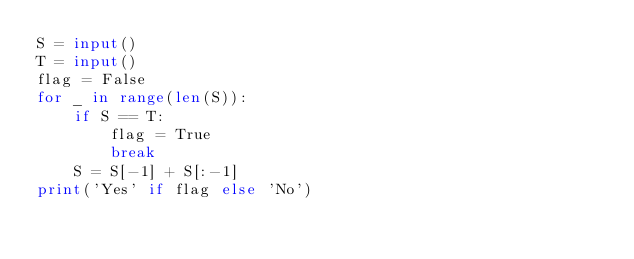<code> <loc_0><loc_0><loc_500><loc_500><_Python_>S = input()
T = input()
flag = False
for _ in range(len(S)):
    if S == T:
        flag = True
        break
    S = S[-1] + S[:-1]
print('Yes' if flag else 'No')
</code> 